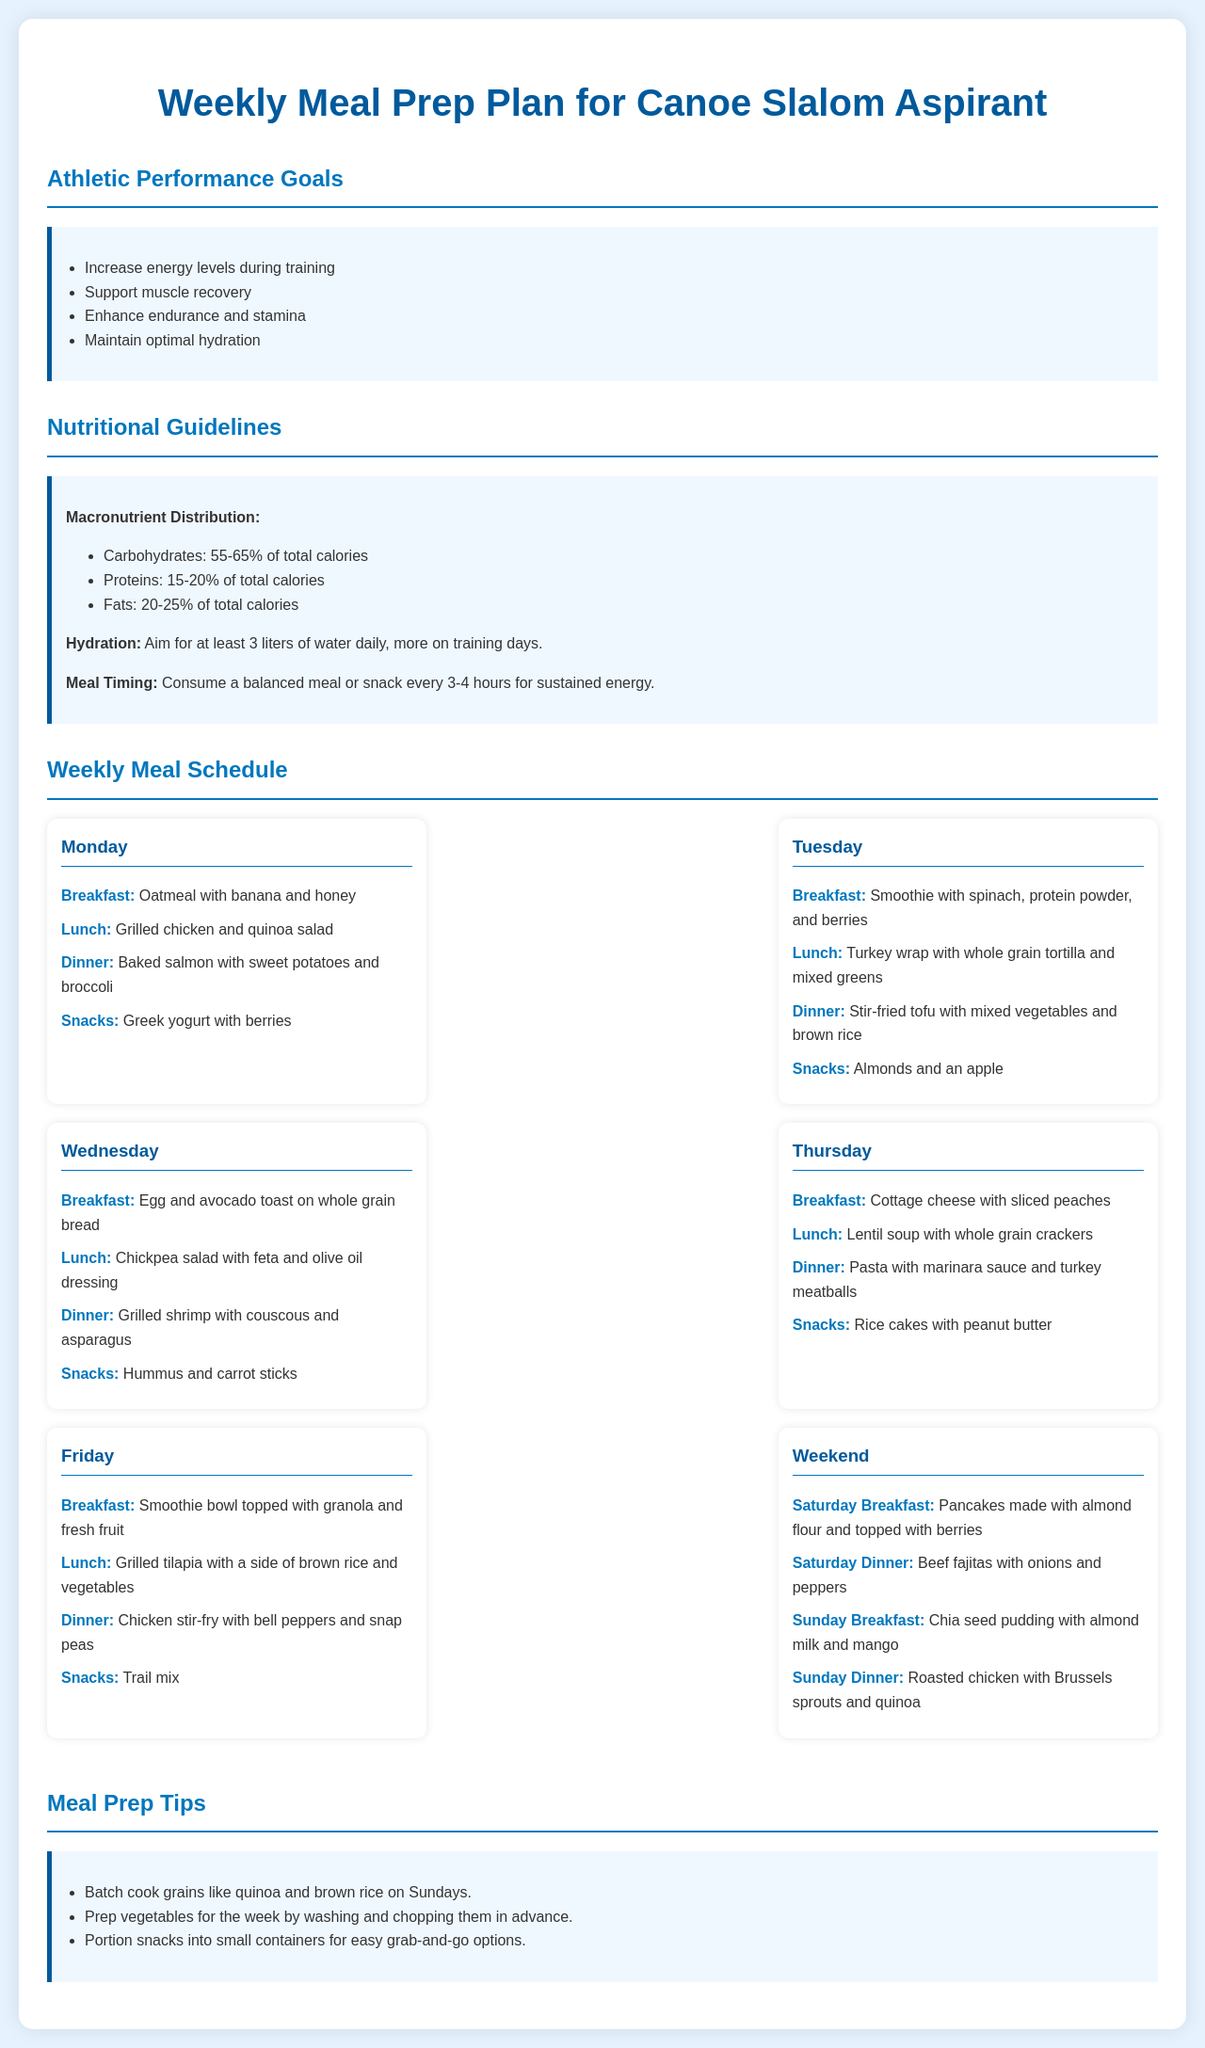What are the athletic performance goals? The document lists the goals related to athletic performance to be achieved through the meal prep plan.
Answer: Increase energy levels during training, Support muscle recovery, Enhance endurance and stamina, Maintain optimal hydration What is the daily water intake recommendation? The hydration guidelines suggest a specific amount of water intake for optimal performance.
Answer: At least 3 liters How many meals or snacks should be consumed daily? The meal timing section mentions how often meals or snacks should be consumed for sustained energy.
Answer: Every 3-4 hours What is the primary protein source for Tuesday's lunch? Tuesday's lunch includes a specific protein-based option.
Answer: Turkey wrap with whole grain tortilla What food is recommended for Saturday's breakfast? The Saturday breakfast section specifically identifies the type of breakfast food.
Answer: Pancakes made with almond flour and topped with berries Which two vegetables are included in Friday's dinner? The Friday dinner lists vegetables that are part of the meal.
Answer: Bell peppers and snap peas What type of soup is scheduled for Thursday's lunch? Thursday's lunch specifies the kind of soup being served.
Answer: Lentil soup What is a suggested strategy for prepping snacks? The meal prep tips provide insights into how to manage snacks effectively for convenience.
Answer: Portion snacks into small containers How is salmon prepared for Monday's dinner? The document specifies the cooking method for the salmon in Monday's dinner.
Answer: Baked salmon 